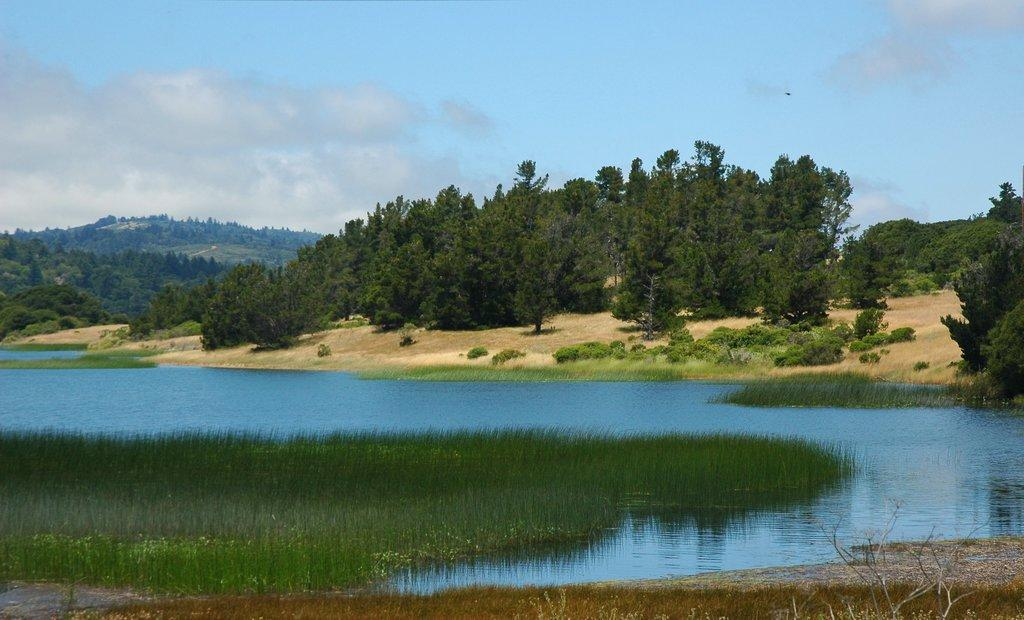What type of vegetation can be seen in the image? There are trees in the image. What geographical feature is present in the image? There is a hill in the image. What type of ground cover is visible in the image? There is grass in the image. What natural element can be seen in the image? There is water visible in the image. What is the condition of the grass in the image? There is dry grass in the image. What is the condition of the sky in the image? The sky is cloudy in the image. Can you tell me where the guide is leading the group through the mist in the image? There is no guide or mist present in the image. What type of quicksand can be seen near the water in the image? There is no quicksand present in the image. 